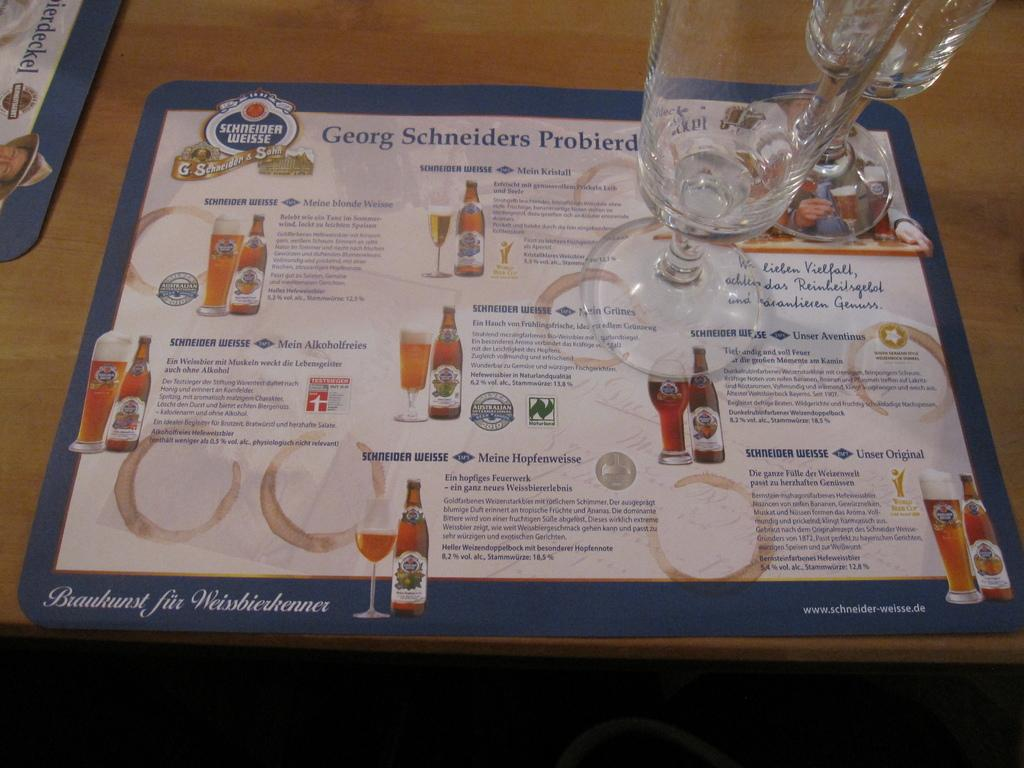<image>
Provide a brief description of the given image. A table mat has a Schneider Weisse logo at the top left. 